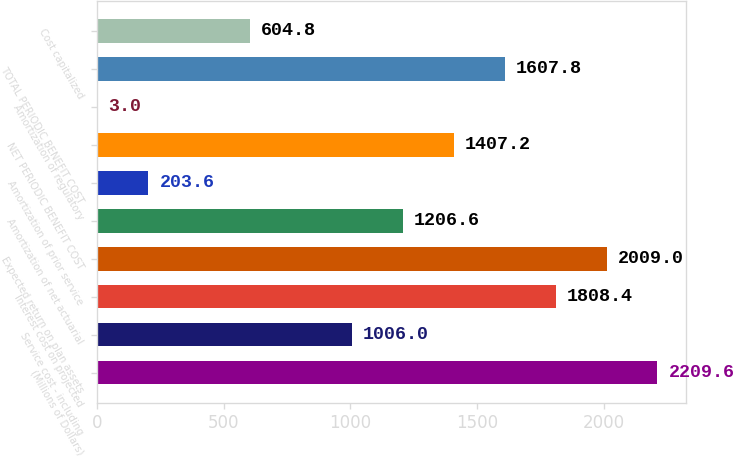Convert chart. <chart><loc_0><loc_0><loc_500><loc_500><bar_chart><fcel>(Millions of Dollars)<fcel>Service cost - including<fcel>Interest cost on projected<fcel>Expected return on plan assets<fcel>Amortization of net actuarial<fcel>Amortization of prior service<fcel>NET PERIODIC BENEFIT COST<fcel>Amortization of regulatory<fcel>TOTAL PERIODIC BENEFIT COST<fcel>Cost capitalized<nl><fcel>2209.6<fcel>1006<fcel>1808.4<fcel>2009<fcel>1206.6<fcel>203.6<fcel>1407.2<fcel>3<fcel>1607.8<fcel>604.8<nl></chart> 